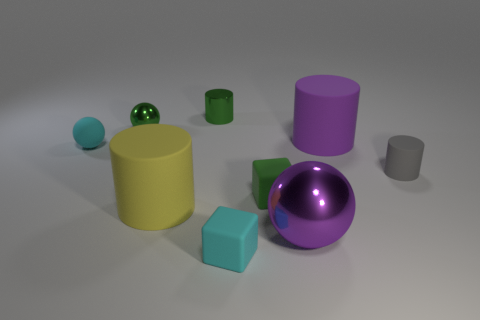There is a small cyan rubber thing that is to the right of the small matte object behind the gray object; what is its shape?
Offer a terse response. Cube. What number of other things are the same color as the tiny metal sphere?
Offer a very short reply. 2. Do the large cylinder that is behind the small matte ball and the tiny green thing on the right side of the tiny green shiny cylinder have the same material?
Provide a succinct answer. Yes. There is a cyan rubber object on the right side of the small green sphere; how big is it?
Keep it short and to the point. Small. There is a tiny cyan thing that is the same shape as the big purple metal thing; what is it made of?
Offer a very short reply. Rubber. Is there any other thing that has the same size as the gray rubber cylinder?
Make the answer very short. Yes. There is a cyan thing behind the small gray matte cylinder; what is its shape?
Your answer should be very brief. Sphere. What number of other objects are the same shape as the big yellow object?
Keep it short and to the point. 3. Is the number of tiny spheres in front of the purple matte cylinder the same as the number of small cubes that are on the right side of the small cyan matte block?
Your response must be concise. Yes. Is there a brown thing made of the same material as the cyan cube?
Offer a very short reply. No. 